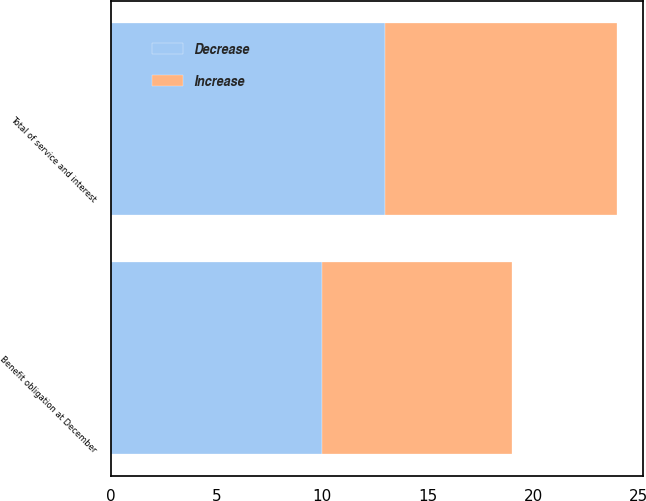Convert chart to OTSL. <chart><loc_0><loc_0><loc_500><loc_500><stacked_bar_chart><ecel><fcel>Total of service and interest<fcel>Benefit obligation at December<nl><fcel>Decrease<fcel>13<fcel>10<nl><fcel>Increase<fcel>11<fcel>9<nl></chart> 